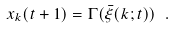<formula> <loc_0><loc_0><loc_500><loc_500>x _ { k } ( t + 1 ) = \Gamma ( { \bar { \xi } } ( k ; t ) ) \ .</formula> 